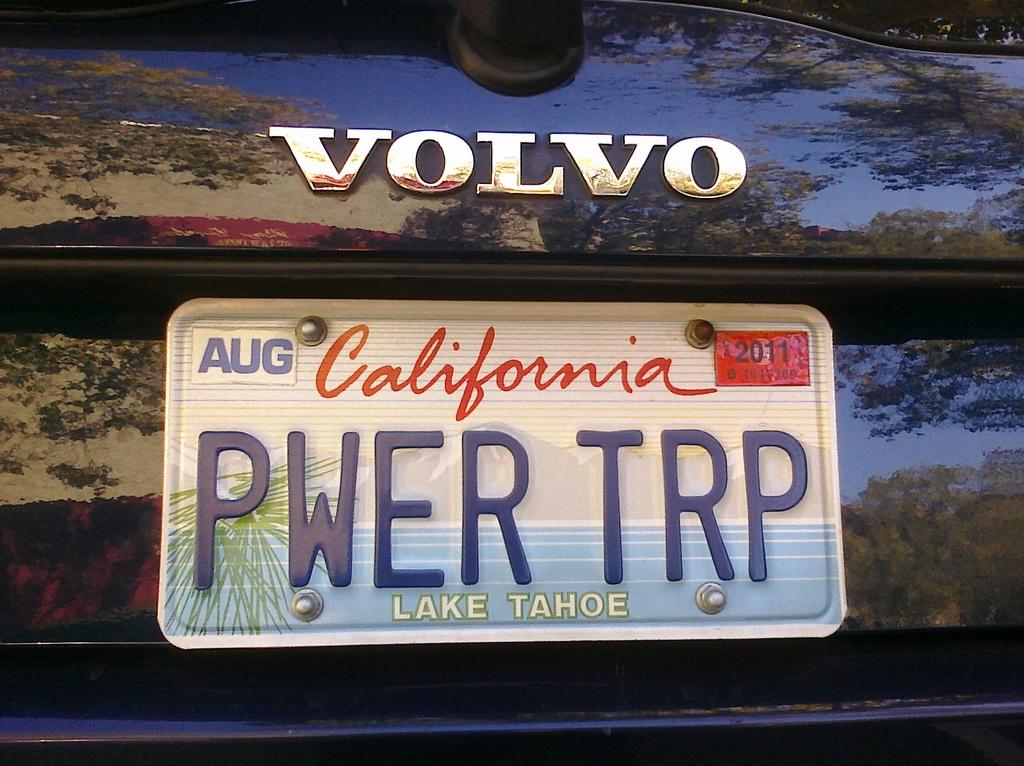Provide a one-sentence caption for the provided image. The registration shown is from Lake Tahoe in California. 